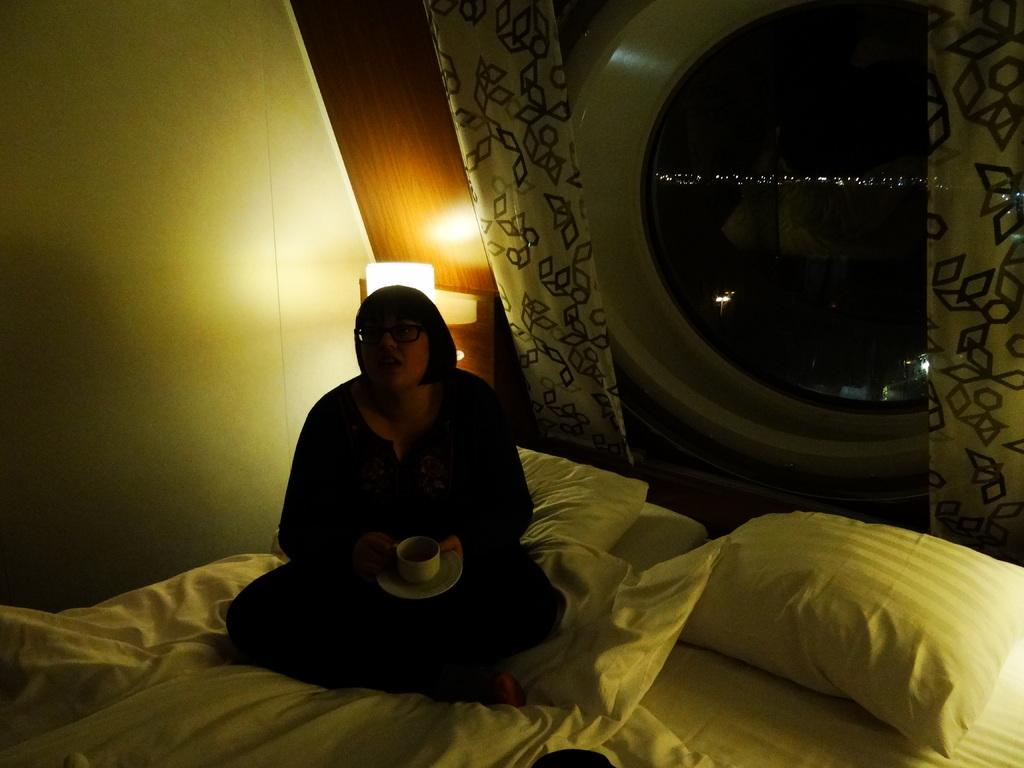Who is present in the image? There is a woman in the image. What is the woman doing in the image? The woman is sitting on a bed. What is the woman holding in the image? The woman is holding a cup and saucer. What can be seen behind the woman in the image? There is a lamp behind the woman. What type of window treatment is present in the image? Two curtains are hanging at the window. What type of powder is visible on the woman's face in the image? There is no powder visible on the woman's face in the image. 